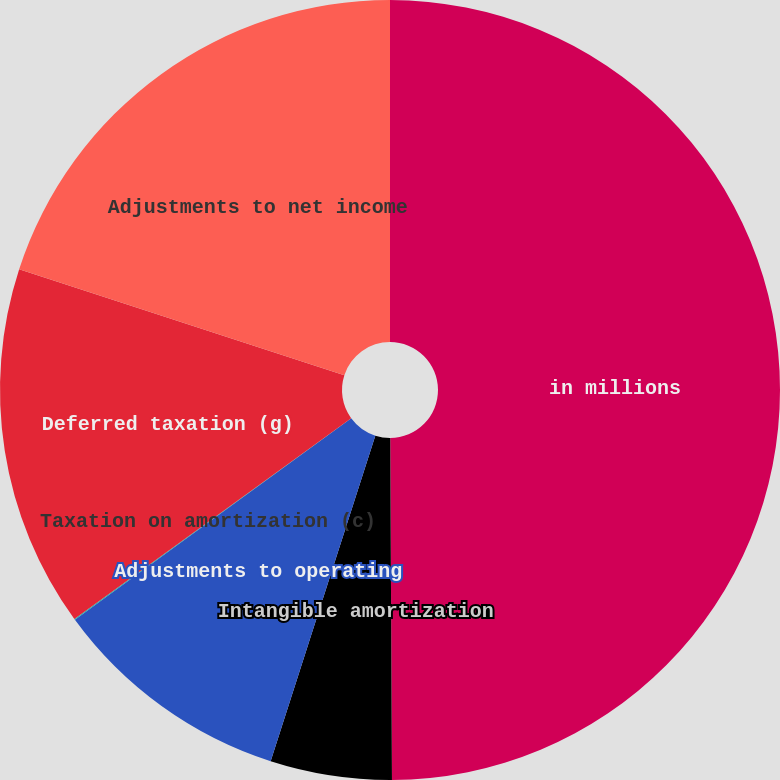Convert chart. <chart><loc_0><loc_0><loc_500><loc_500><pie_chart><fcel>in millions<fcel>Intangible amortization<fcel>Adjustments to operating<fcel>Taxation on amortization (c)<fcel>Deferred taxation (g)<fcel>Adjustments to net income<nl><fcel>49.92%<fcel>5.03%<fcel>10.02%<fcel>0.04%<fcel>15.0%<fcel>19.99%<nl></chart> 